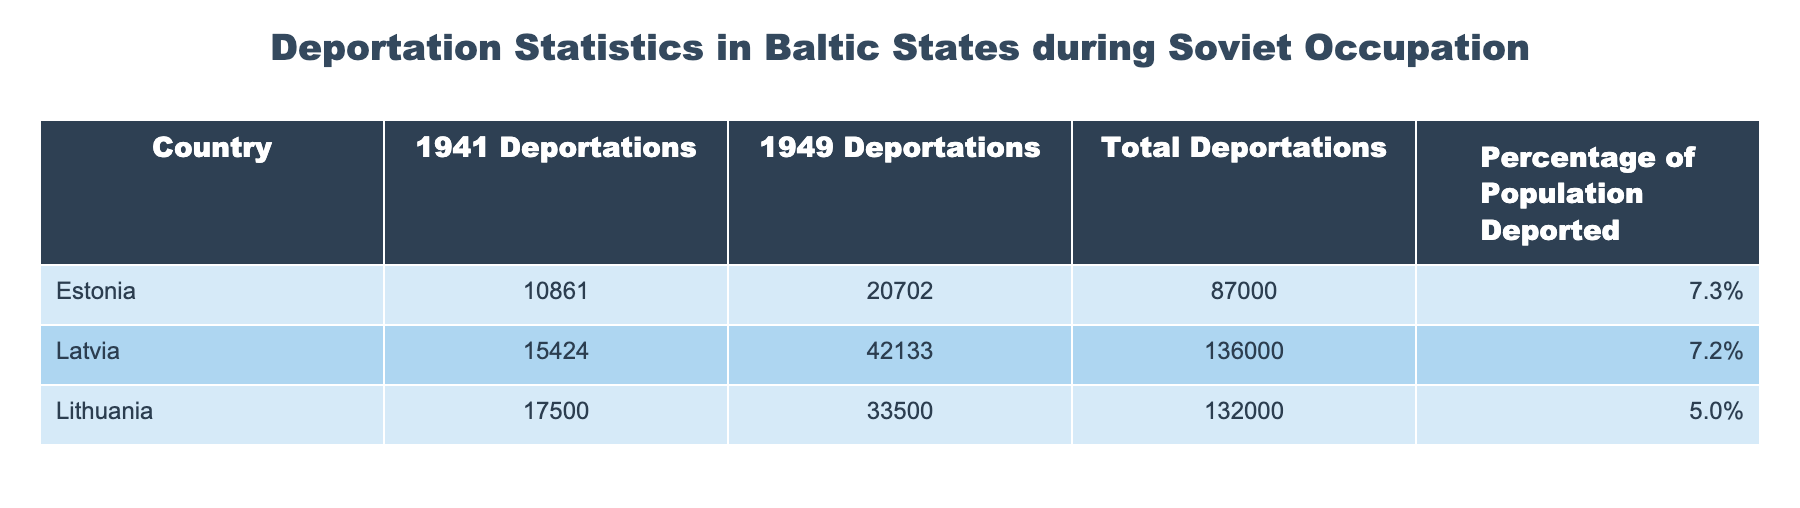What is the total number of deportations from Estonia? The table directly lists the total number of deportations from Estonia as 87000.
Answer: 87000 Which country had the highest number of deportations in 1949? Looking at the 1949 Deportations column, Latvia has the highest number listed with 42133 deportations.
Answer: Latvia What is the percentage of the population deported from Lithuania? From the table, Lithuania's percentage of the population deported is listed as 5.0%.
Answer: 5.0% How many more people were deported from Latvia in 1941 compared to Estonia? To find the difference, we subtract Estonia's 1941 deportations (10861) from Latvia's (15424). Thus, 15424 - 10861 = 4573.
Answer: 4573 Is the percentage of the population deported from Estonia higher than from Latvia? The table shows Estonia at 7.3% and Latvia at 7.2%, so Estonia's percentage is indeed higher than Latvia's.
Answer: Yes What is the combined total number of deportations from Estonia and Lithuania? To find the combined total, we add the total deportations from Estonia (87000) and Lithuania (132000): 87000 + 132000 = 218000.
Answer: 218000 Which country had the lowest total percentage of its population deported? By comparing the percentages, Lithuania has the lowest total percentage of its population deported at 5.0%.
Answer: Lithuania If we consider just the 1941 deportations, which country had the least? The 1941 Deportations for Estonia (10861), Latvia (15424), and Lithuania (17500) show Estonia had the least with 10861.
Answer: Estonia What is the average percentage of the population deported across the three Baltic states? To find the average, we sum the percentages: 7.3% + 7.2% + 5.0% = 19.5%. Then we divide by 3: 19.5% / 3 = 6.5%.
Answer: 6.5% 